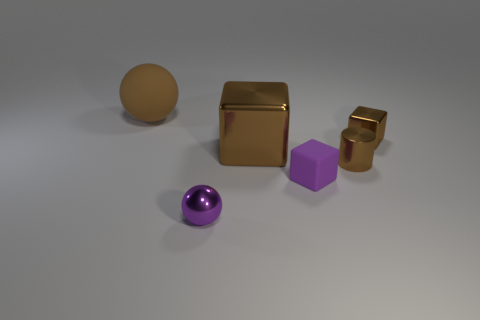There is a small cube that is made of the same material as the tiny sphere; what is its color?
Ensure brevity in your answer.  Brown. What number of brown cylinders are the same size as the purple sphere?
Offer a terse response. 1. There is a thing that is to the left of the purple metallic ball; is it the same size as the cylinder?
Ensure brevity in your answer.  No. What is the shape of the thing that is both behind the small purple shiny sphere and in front of the cylinder?
Provide a short and direct response. Cube. Are there any purple rubber blocks in front of the metal ball?
Your answer should be very brief. No. Is there anything else that has the same shape as the brown matte object?
Make the answer very short. Yes. Is the large rubber thing the same shape as the tiny purple metal thing?
Provide a short and direct response. Yes. Is the number of big metallic things that are on the right side of the big block the same as the number of small spheres right of the tiny purple metal ball?
Offer a very short reply. Yes. How many other objects are there of the same material as the purple block?
Your response must be concise. 1. What number of big things are shiny spheres or gray blocks?
Keep it short and to the point. 0. 